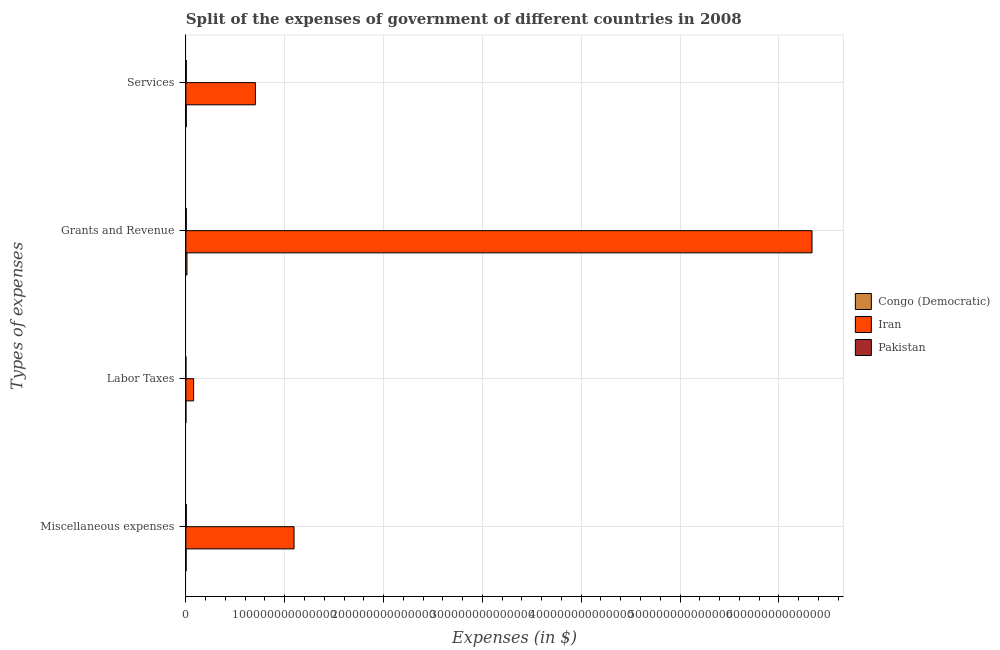How many different coloured bars are there?
Ensure brevity in your answer.  3. Are the number of bars on each tick of the Y-axis equal?
Ensure brevity in your answer.  Yes. How many bars are there on the 4th tick from the top?
Ensure brevity in your answer.  3. What is the label of the 4th group of bars from the top?
Ensure brevity in your answer.  Miscellaneous expenses. What is the amount spent on grants and revenue in Iran?
Give a very brief answer. 6.34e+14. Across all countries, what is the maximum amount spent on grants and revenue?
Keep it short and to the point. 6.34e+14. Across all countries, what is the minimum amount spent on grants and revenue?
Give a very brief answer. 3.98e+11. In which country was the amount spent on miscellaneous expenses maximum?
Keep it short and to the point. Iran. What is the total amount spent on labor taxes in the graph?
Give a very brief answer. 7.89e+12. What is the difference between the amount spent on labor taxes in Pakistan and that in Congo (Democratic)?
Your response must be concise. 1.94e+09. What is the difference between the amount spent on services in Congo (Democratic) and the amount spent on grants and revenue in Iran?
Offer a terse response. -6.33e+14. What is the average amount spent on services per country?
Your answer should be very brief. 2.37e+13. What is the difference between the amount spent on miscellaneous expenses and amount spent on grants and revenue in Iran?
Provide a short and direct response. -5.24e+14. What is the ratio of the amount spent on grants and revenue in Iran to that in Pakistan?
Make the answer very short. 1589.93. Is the amount spent on services in Congo (Democratic) less than that in Pakistan?
Provide a succinct answer. No. What is the difference between the highest and the second highest amount spent on services?
Provide a succinct answer. 6.99e+13. What is the difference between the highest and the lowest amount spent on services?
Your response must be concise. 6.99e+13. Is the sum of the amount spent on grants and revenue in Congo (Democratic) and Pakistan greater than the maximum amount spent on services across all countries?
Your answer should be compact. No. What does the 3rd bar from the top in Labor Taxes represents?
Ensure brevity in your answer.  Congo (Democratic). How many countries are there in the graph?
Give a very brief answer. 3. What is the difference between two consecutive major ticks on the X-axis?
Give a very brief answer. 1.00e+14. Are the values on the major ticks of X-axis written in scientific E-notation?
Your response must be concise. No. Does the graph contain any zero values?
Your answer should be very brief. No. What is the title of the graph?
Offer a very short reply. Split of the expenses of government of different countries in 2008. What is the label or title of the X-axis?
Keep it short and to the point. Expenses (in $). What is the label or title of the Y-axis?
Provide a short and direct response. Types of expenses. What is the Expenses (in $) in Congo (Democratic) in Miscellaneous expenses?
Your answer should be compact. 2.56e+11. What is the Expenses (in $) in Iran in Miscellaneous expenses?
Keep it short and to the point. 1.09e+14. What is the Expenses (in $) in Pakistan in Miscellaneous expenses?
Ensure brevity in your answer.  4.31e+11. What is the Expenses (in $) in Congo (Democratic) in Labor Taxes?
Provide a short and direct response. 1.27e+1. What is the Expenses (in $) in Iran in Labor Taxes?
Your answer should be compact. 7.87e+12. What is the Expenses (in $) of Pakistan in Labor Taxes?
Provide a succinct answer. 1.47e+1. What is the Expenses (in $) of Congo (Democratic) in Grants and Revenue?
Provide a succinct answer. 1.13e+12. What is the Expenses (in $) in Iran in Grants and Revenue?
Your answer should be very brief. 6.34e+14. What is the Expenses (in $) of Pakistan in Grants and Revenue?
Offer a very short reply. 3.98e+11. What is the Expenses (in $) of Congo (Democratic) in Services?
Your answer should be very brief. 4.04e+11. What is the Expenses (in $) of Iran in Services?
Provide a short and direct response. 7.03e+13. What is the Expenses (in $) of Pakistan in Services?
Provide a succinct answer. 3.98e+11. Across all Types of expenses, what is the maximum Expenses (in $) in Congo (Democratic)?
Your answer should be very brief. 1.13e+12. Across all Types of expenses, what is the maximum Expenses (in $) in Iran?
Offer a terse response. 6.34e+14. Across all Types of expenses, what is the maximum Expenses (in $) in Pakistan?
Your answer should be compact. 4.31e+11. Across all Types of expenses, what is the minimum Expenses (in $) in Congo (Democratic)?
Make the answer very short. 1.27e+1. Across all Types of expenses, what is the minimum Expenses (in $) in Iran?
Offer a very short reply. 7.87e+12. Across all Types of expenses, what is the minimum Expenses (in $) in Pakistan?
Your response must be concise. 1.47e+1. What is the total Expenses (in $) of Congo (Democratic) in the graph?
Offer a terse response. 1.80e+12. What is the total Expenses (in $) of Iran in the graph?
Provide a short and direct response. 8.21e+14. What is the total Expenses (in $) in Pakistan in the graph?
Provide a short and direct response. 1.24e+12. What is the difference between the Expenses (in $) of Congo (Democratic) in Miscellaneous expenses and that in Labor Taxes?
Your response must be concise. 2.43e+11. What is the difference between the Expenses (in $) of Iran in Miscellaneous expenses and that in Labor Taxes?
Ensure brevity in your answer.  1.02e+14. What is the difference between the Expenses (in $) of Pakistan in Miscellaneous expenses and that in Labor Taxes?
Your answer should be very brief. 4.17e+11. What is the difference between the Expenses (in $) in Congo (Democratic) in Miscellaneous expenses and that in Grants and Revenue?
Your answer should be very brief. -8.71e+11. What is the difference between the Expenses (in $) of Iran in Miscellaneous expenses and that in Grants and Revenue?
Offer a terse response. -5.24e+14. What is the difference between the Expenses (in $) in Pakistan in Miscellaneous expenses and that in Grants and Revenue?
Provide a short and direct response. 3.29e+1. What is the difference between the Expenses (in $) of Congo (Democratic) in Miscellaneous expenses and that in Services?
Make the answer very short. -1.49e+11. What is the difference between the Expenses (in $) of Iran in Miscellaneous expenses and that in Services?
Provide a short and direct response. 3.91e+13. What is the difference between the Expenses (in $) in Pakistan in Miscellaneous expenses and that in Services?
Your response must be concise. 3.35e+1. What is the difference between the Expenses (in $) in Congo (Democratic) in Labor Taxes and that in Grants and Revenue?
Your response must be concise. -1.11e+12. What is the difference between the Expenses (in $) in Iran in Labor Taxes and that in Grants and Revenue?
Provide a short and direct response. -6.26e+14. What is the difference between the Expenses (in $) of Pakistan in Labor Taxes and that in Grants and Revenue?
Your answer should be compact. -3.84e+11. What is the difference between the Expenses (in $) of Congo (Democratic) in Labor Taxes and that in Services?
Give a very brief answer. -3.91e+11. What is the difference between the Expenses (in $) in Iran in Labor Taxes and that in Services?
Your answer should be very brief. -6.24e+13. What is the difference between the Expenses (in $) in Pakistan in Labor Taxes and that in Services?
Make the answer very short. -3.83e+11. What is the difference between the Expenses (in $) of Congo (Democratic) in Grants and Revenue and that in Services?
Keep it short and to the point. 7.22e+11. What is the difference between the Expenses (in $) in Iran in Grants and Revenue and that in Services?
Provide a short and direct response. 5.63e+14. What is the difference between the Expenses (in $) in Pakistan in Grants and Revenue and that in Services?
Give a very brief answer. 5.83e+08. What is the difference between the Expenses (in $) of Congo (Democratic) in Miscellaneous expenses and the Expenses (in $) of Iran in Labor Taxes?
Provide a short and direct response. -7.61e+12. What is the difference between the Expenses (in $) of Congo (Democratic) in Miscellaneous expenses and the Expenses (in $) of Pakistan in Labor Taxes?
Give a very brief answer. 2.41e+11. What is the difference between the Expenses (in $) of Iran in Miscellaneous expenses and the Expenses (in $) of Pakistan in Labor Taxes?
Your answer should be compact. 1.09e+14. What is the difference between the Expenses (in $) in Congo (Democratic) in Miscellaneous expenses and the Expenses (in $) in Iran in Grants and Revenue?
Your response must be concise. -6.33e+14. What is the difference between the Expenses (in $) in Congo (Democratic) in Miscellaneous expenses and the Expenses (in $) in Pakistan in Grants and Revenue?
Provide a succinct answer. -1.43e+11. What is the difference between the Expenses (in $) of Iran in Miscellaneous expenses and the Expenses (in $) of Pakistan in Grants and Revenue?
Offer a very short reply. 1.09e+14. What is the difference between the Expenses (in $) in Congo (Democratic) in Miscellaneous expenses and the Expenses (in $) in Iran in Services?
Provide a short and direct response. -7.01e+13. What is the difference between the Expenses (in $) in Congo (Democratic) in Miscellaneous expenses and the Expenses (in $) in Pakistan in Services?
Give a very brief answer. -1.42e+11. What is the difference between the Expenses (in $) in Iran in Miscellaneous expenses and the Expenses (in $) in Pakistan in Services?
Make the answer very short. 1.09e+14. What is the difference between the Expenses (in $) of Congo (Democratic) in Labor Taxes and the Expenses (in $) of Iran in Grants and Revenue?
Your answer should be very brief. -6.34e+14. What is the difference between the Expenses (in $) in Congo (Democratic) in Labor Taxes and the Expenses (in $) in Pakistan in Grants and Revenue?
Provide a short and direct response. -3.86e+11. What is the difference between the Expenses (in $) of Iran in Labor Taxes and the Expenses (in $) of Pakistan in Grants and Revenue?
Offer a terse response. 7.47e+12. What is the difference between the Expenses (in $) of Congo (Democratic) in Labor Taxes and the Expenses (in $) of Iran in Services?
Provide a succinct answer. -7.03e+13. What is the difference between the Expenses (in $) of Congo (Democratic) in Labor Taxes and the Expenses (in $) of Pakistan in Services?
Keep it short and to the point. -3.85e+11. What is the difference between the Expenses (in $) in Iran in Labor Taxes and the Expenses (in $) in Pakistan in Services?
Offer a terse response. 7.47e+12. What is the difference between the Expenses (in $) of Congo (Democratic) in Grants and Revenue and the Expenses (in $) of Iran in Services?
Your response must be concise. -6.92e+13. What is the difference between the Expenses (in $) of Congo (Democratic) in Grants and Revenue and the Expenses (in $) of Pakistan in Services?
Ensure brevity in your answer.  7.28e+11. What is the difference between the Expenses (in $) in Iran in Grants and Revenue and the Expenses (in $) in Pakistan in Services?
Make the answer very short. 6.33e+14. What is the average Expenses (in $) of Congo (Democratic) per Types of expenses?
Offer a very short reply. 4.50e+11. What is the average Expenses (in $) of Iran per Types of expenses?
Your response must be concise. 2.05e+14. What is the average Expenses (in $) of Pakistan per Types of expenses?
Give a very brief answer. 3.11e+11. What is the difference between the Expenses (in $) of Congo (Democratic) and Expenses (in $) of Iran in Miscellaneous expenses?
Give a very brief answer. -1.09e+14. What is the difference between the Expenses (in $) in Congo (Democratic) and Expenses (in $) in Pakistan in Miscellaneous expenses?
Offer a very short reply. -1.76e+11. What is the difference between the Expenses (in $) of Iran and Expenses (in $) of Pakistan in Miscellaneous expenses?
Offer a terse response. 1.09e+14. What is the difference between the Expenses (in $) of Congo (Democratic) and Expenses (in $) of Iran in Labor Taxes?
Your answer should be very brief. -7.85e+12. What is the difference between the Expenses (in $) in Congo (Democratic) and Expenses (in $) in Pakistan in Labor Taxes?
Offer a very short reply. -1.94e+09. What is the difference between the Expenses (in $) of Iran and Expenses (in $) of Pakistan in Labor Taxes?
Ensure brevity in your answer.  7.85e+12. What is the difference between the Expenses (in $) of Congo (Democratic) and Expenses (in $) of Iran in Grants and Revenue?
Your answer should be very brief. -6.32e+14. What is the difference between the Expenses (in $) of Congo (Democratic) and Expenses (in $) of Pakistan in Grants and Revenue?
Your answer should be compact. 7.28e+11. What is the difference between the Expenses (in $) of Iran and Expenses (in $) of Pakistan in Grants and Revenue?
Provide a succinct answer. 6.33e+14. What is the difference between the Expenses (in $) of Congo (Democratic) and Expenses (in $) of Iran in Services?
Ensure brevity in your answer.  -6.99e+13. What is the difference between the Expenses (in $) in Congo (Democratic) and Expenses (in $) in Pakistan in Services?
Give a very brief answer. 6.21e+09. What is the difference between the Expenses (in $) in Iran and Expenses (in $) in Pakistan in Services?
Provide a succinct answer. 6.99e+13. What is the ratio of the Expenses (in $) of Congo (Democratic) in Miscellaneous expenses to that in Labor Taxes?
Your answer should be compact. 20.05. What is the ratio of the Expenses (in $) in Iran in Miscellaneous expenses to that in Labor Taxes?
Your response must be concise. 13.91. What is the ratio of the Expenses (in $) in Pakistan in Miscellaneous expenses to that in Labor Taxes?
Provide a short and direct response. 29.38. What is the ratio of the Expenses (in $) of Congo (Democratic) in Miscellaneous expenses to that in Grants and Revenue?
Make the answer very short. 0.23. What is the ratio of the Expenses (in $) of Iran in Miscellaneous expenses to that in Grants and Revenue?
Your response must be concise. 0.17. What is the ratio of the Expenses (in $) in Pakistan in Miscellaneous expenses to that in Grants and Revenue?
Your answer should be very brief. 1.08. What is the ratio of the Expenses (in $) of Congo (Democratic) in Miscellaneous expenses to that in Services?
Make the answer very short. 0.63. What is the ratio of the Expenses (in $) of Iran in Miscellaneous expenses to that in Services?
Ensure brevity in your answer.  1.56. What is the ratio of the Expenses (in $) in Pakistan in Miscellaneous expenses to that in Services?
Ensure brevity in your answer.  1.08. What is the ratio of the Expenses (in $) of Congo (Democratic) in Labor Taxes to that in Grants and Revenue?
Provide a short and direct response. 0.01. What is the ratio of the Expenses (in $) of Iran in Labor Taxes to that in Grants and Revenue?
Ensure brevity in your answer.  0.01. What is the ratio of the Expenses (in $) in Pakistan in Labor Taxes to that in Grants and Revenue?
Your answer should be compact. 0.04. What is the ratio of the Expenses (in $) of Congo (Democratic) in Labor Taxes to that in Services?
Give a very brief answer. 0.03. What is the ratio of the Expenses (in $) in Iran in Labor Taxes to that in Services?
Provide a short and direct response. 0.11. What is the ratio of the Expenses (in $) of Pakistan in Labor Taxes to that in Services?
Keep it short and to the point. 0.04. What is the ratio of the Expenses (in $) of Congo (Democratic) in Grants and Revenue to that in Services?
Make the answer very short. 2.79. What is the ratio of the Expenses (in $) in Iran in Grants and Revenue to that in Services?
Ensure brevity in your answer.  9.01. What is the difference between the highest and the second highest Expenses (in $) in Congo (Democratic)?
Make the answer very short. 7.22e+11. What is the difference between the highest and the second highest Expenses (in $) of Iran?
Make the answer very short. 5.24e+14. What is the difference between the highest and the second highest Expenses (in $) in Pakistan?
Provide a succinct answer. 3.29e+1. What is the difference between the highest and the lowest Expenses (in $) of Congo (Democratic)?
Provide a succinct answer. 1.11e+12. What is the difference between the highest and the lowest Expenses (in $) in Iran?
Provide a short and direct response. 6.26e+14. What is the difference between the highest and the lowest Expenses (in $) of Pakistan?
Keep it short and to the point. 4.17e+11. 